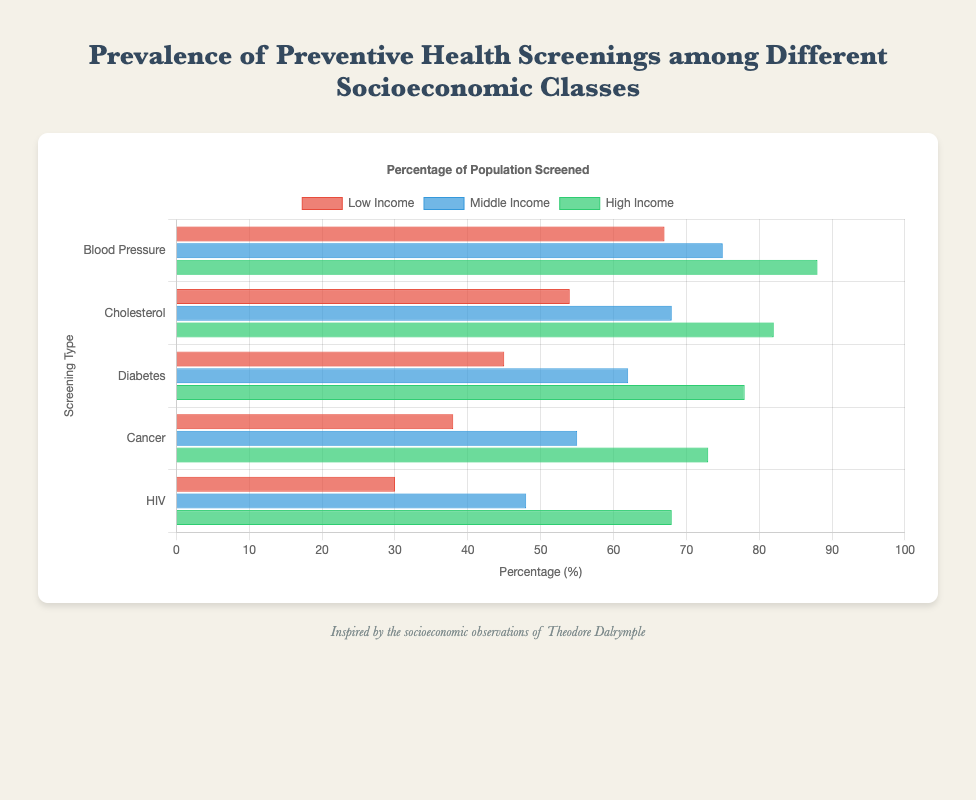Which socioeconomic class has the highest percentage of Blood Pressure Screening? By observing the horizontal bars corresponding to Blood Pressure Screening, the green bar representing the High Income class is the longest, indicating the highest percentage.
Answer: High Income What is the difference in Cholesterol Screening prevalence between Low Income and Middle Income classes? The prevalence for Low Income is 54%, and for Middle Income, it is 68%. The difference can be computed as 68% - 54% = 14%.
Answer: 14% How much higher is the percentage of HIV Screening in High Income compared to Low Income? High Income has a prevalence of 68%, while Low Income has 30%. The difference is calculated by 68% - 30% = 38%.
Answer: 38% Which screening type shows the largest gap in prevalence between Low Income and High Income classes? By comparing the differences for all screening types, Blood Pressure Screening has a difference of 88% - 67% = 21%, Cholesterol Screening has 82% - 54% = 28%, Diabetes Screening has 78% - 45% = 33%, Cancer Screening has 73% - 38% = 35%, and HIV Screening has 68% - 30% = 38%. The largest gap is in HIV Screening.
Answer: HIV Screening Among Cancer Screenings, which income class shows the second-highest prevalence? By comparing the lengths of the bars for Cancer Screening, the green bar (High Income) is longest at 73%, followed by the blue bar (Middle Income) at 55%, and the shortest is the red bar (Low Income) at 38%.
Answer: Middle Income What is the overall average percentage for Diabetes Screening across all socioeconomic classes? The prevalence is 45% for Low Income, 62% for Middle Income, and 78% for High Income. The average can be calculated as (45 + 62 + 78) / 3 = 185 / 3 ≈ 61.67%.
Answer: 61.67% Which type of screening does the Low Income class have the least percentage of? Observing the lengths of the red bars for the Low Income class, the shortest bar corresponds to HIV Screening at 30%.
Answer: HIV Screening 